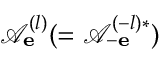Convert formula to latex. <formula><loc_0><loc_0><loc_500><loc_500>\mathcal { A } _ { e } ^ { ( l ) } ( = \mathcal { A } _ { - e } ^ { ( - l ) * } )</formula> 